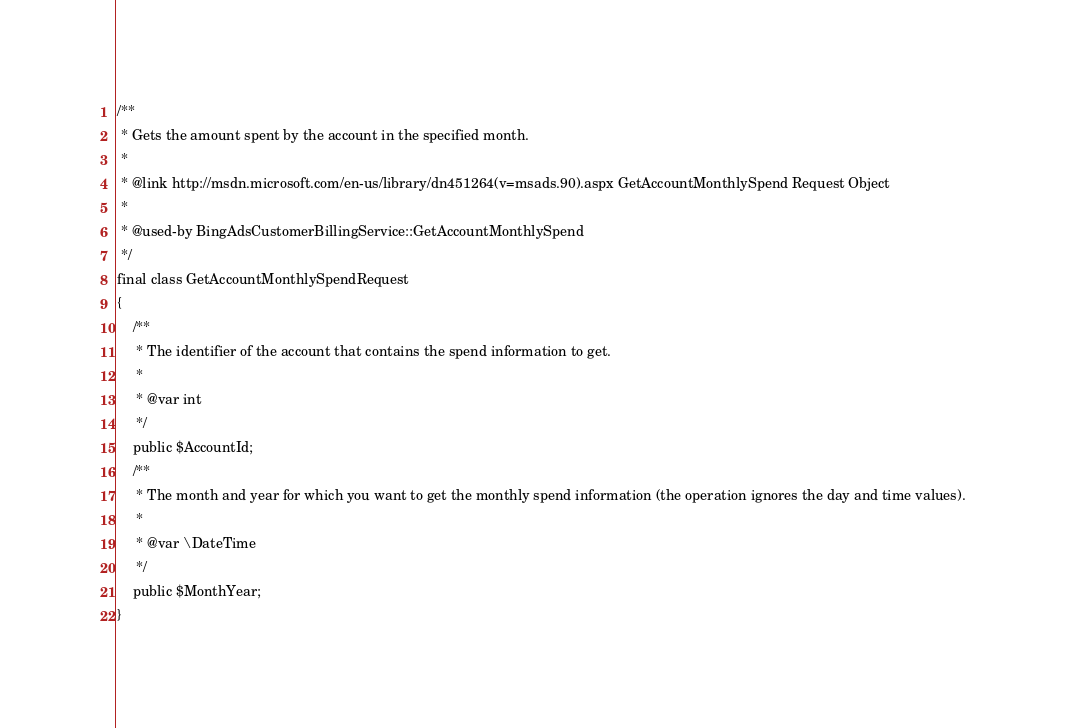<code> <loc_0><loc_0><loc_500><loc_500><_PHP_>
/**
 * Gets the amount spent by the account in the specified month.
 *
 * @link http://msdn.microsoft.com/en-us/library/dn451264(v=msads.90).aspx GetAccountMonthlySpend Request Object
 *
 * @used-by BingAdsCustomerBillingService::GetAccountMonthlySpend
 */
final class GetAccountMonthlySpendRequest
{
    /**
     * The identifier of the account that contains the spend information to get.
     *
     * @var int
     */
    public $AccountId;
    /**
     * The month and year for which you want to get the monthly spend information (the operation ignores the day and time values).
     *
     * @var \DateTime
     */
    public $MonthYear;
}
</code> 